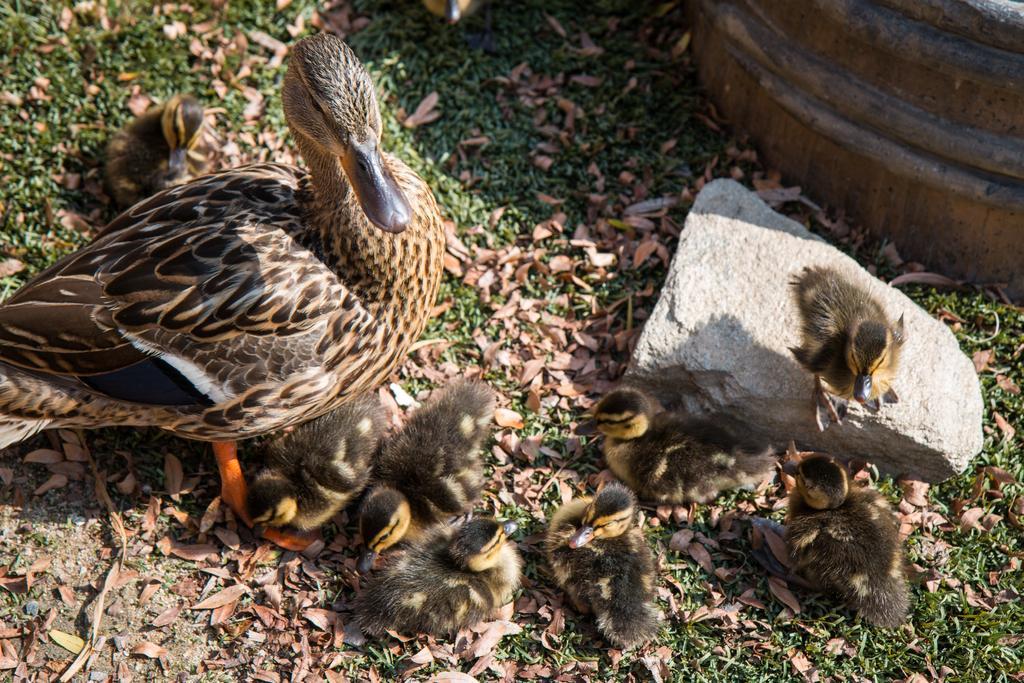Describe this image in one or two sentences. In this image there is duck and ducklings in a green land, beside the ducklings there is a stone on that stone there is a duckling, beside the stone there is an object. 